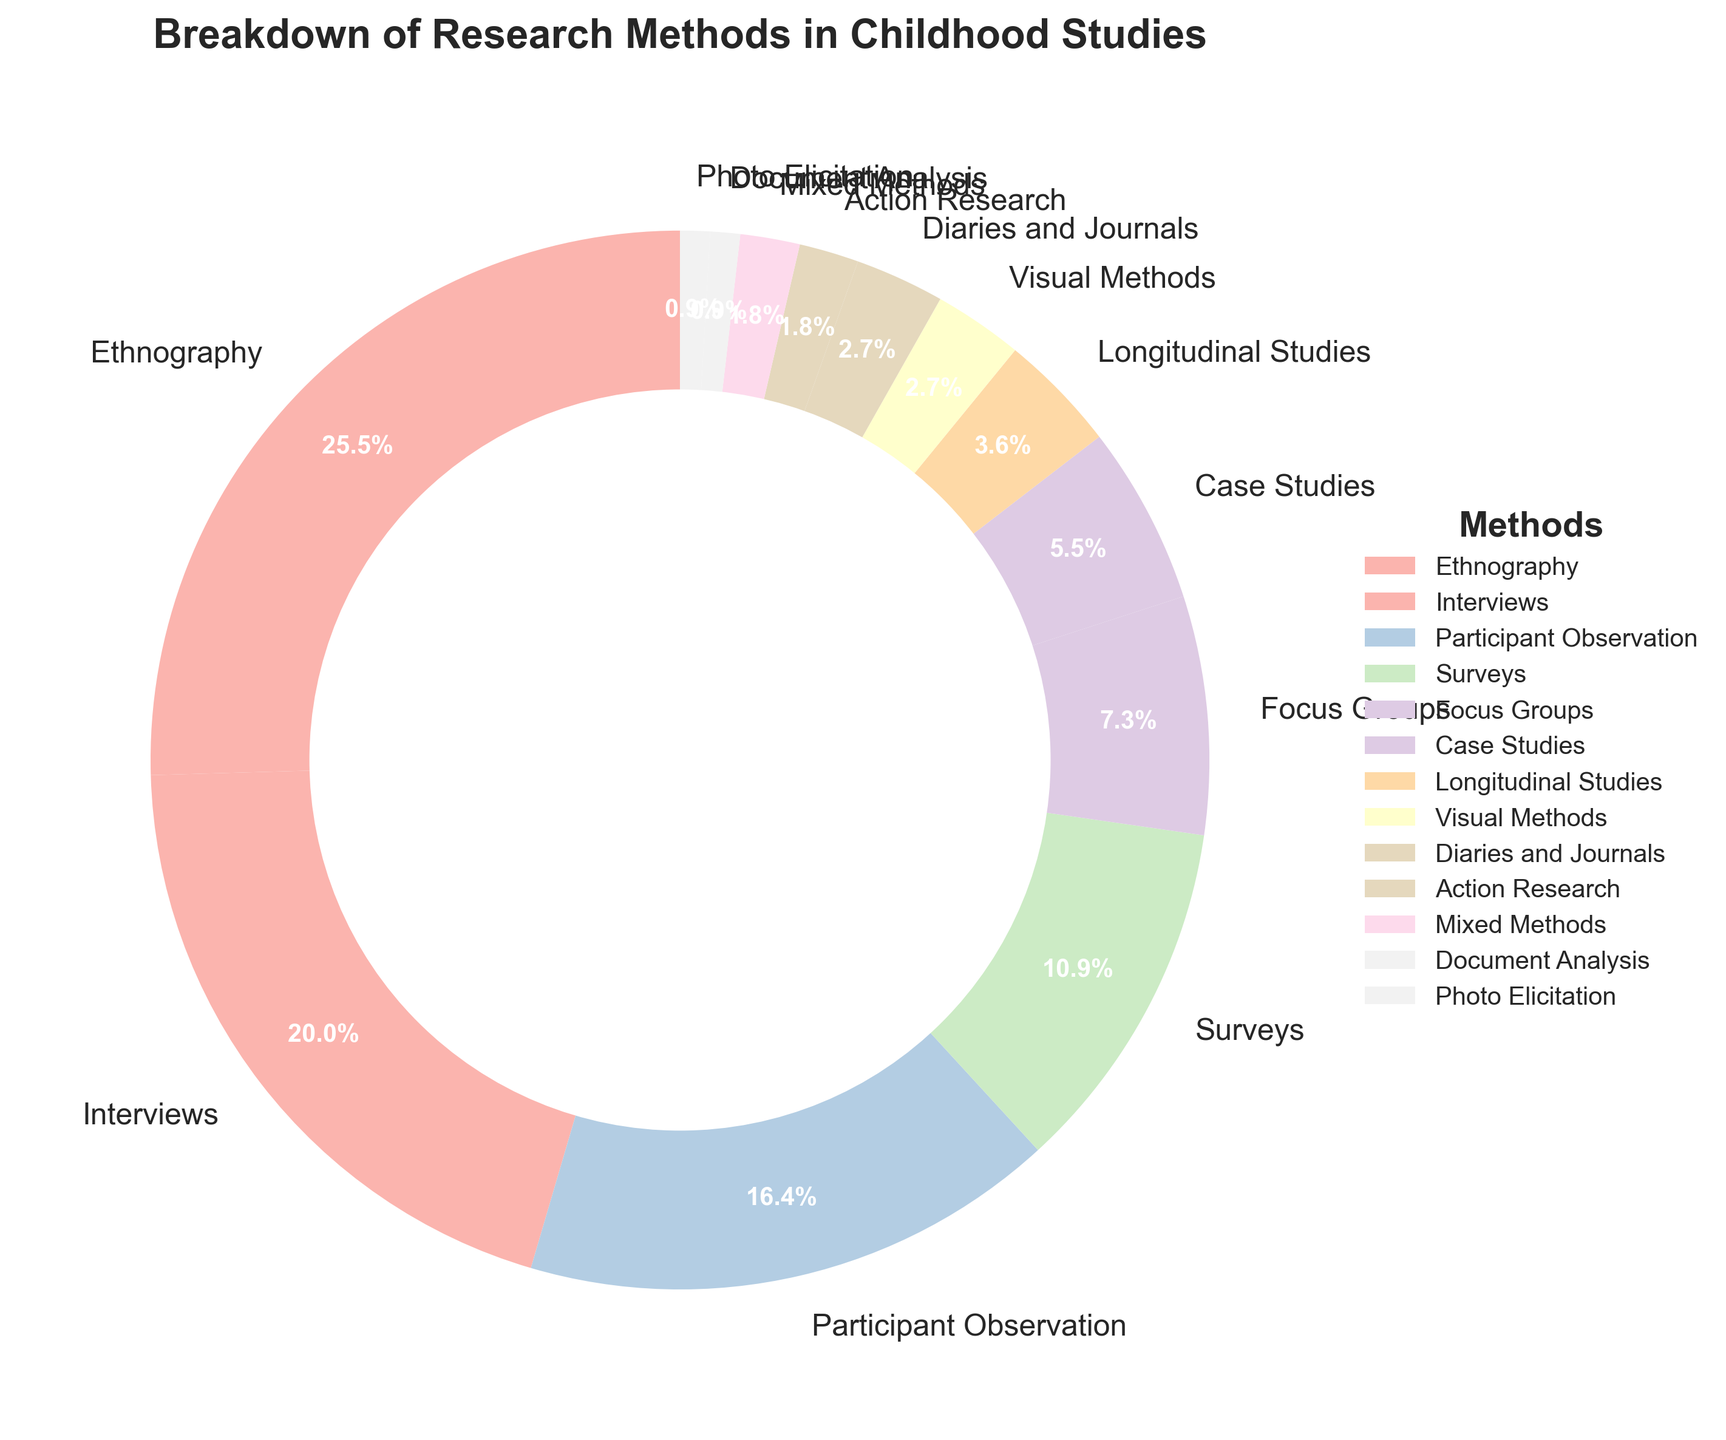Which research method is used the most in childhood studies? The pie chart shows that Ethnography has the largest section, indicating it is the most used method.
Answer: Ethnography What combination of methods makes up exactly half of the research methods used? To find this, sum the percentages until you reach 50%. Ethnography (28%) + Interviews (22%) = 50%.
Answer: Ethnography and Interviews Which method is used least frequently in childhood studies? The smallest section in the pie chart is labeled as Document Analysis and Photo Elicitation.
Answer: Document Analysis and Photo Elicitation How much more frequently are Ethnography and Interviews combined used compared to Surveys? Ethnography (28%) + Interviews (22%) = 50%. Surveys are 12%. The difference is 50% - 12% = 38%.
Answer: 38% What methods together contribute to more than 75% of the research? Summing the largest contributors until exceeding 75%: Ethnography (28%) + Interviews (22%) + Participant Observation (18%) + Surveys (12%) = 80%.
Answer: Ethnography, Interviews, Participant Observation, and Surveys How does the percentage of Participant Observation compare to Focus Groups? Participant Observation is shown as 18%, while Focus Groups are 8%. Thus, Participant Observation is more frequent by 10 percentage points.
Answer: Participant Observation is 10 percentage points higher Which methods contribute less than 5% to the total? From the chart, the methods that contribute less than 5% are Longitudinal Studies (4%), Visual Methods (3%), Diaries and Journals (3%), Action Research (2%), Mixed Methods (2%), Document Analysis (1%), and Photo Elicitation (1%).
Answer: Longitudinal Studies, Visual Methods, Diaries and Journals, Action Research, Mixed Methods, Document Analysis, Photo Elicitation How many methods are used at exactly the same percentage? The chart shows Visual Methods (3%) and Diaries and Journals (3%) are both at the same percentage.
Answer: Two methods What is the total percentage of methods that contribute less than 10%? Summing the percentages of methods contributing less than 10%: 8% (Focus Groups) + 6% (Case Studies) + 4% (Longitudinal Studies) + 3% (Visual Methods) + 3% (Diaries and Journals) + 2% (Action Research) + 2% (Mixed Methods) + 1% (Document Analysis) + 1% (Photo Elicitation) = 30%.
Answer: 30% 